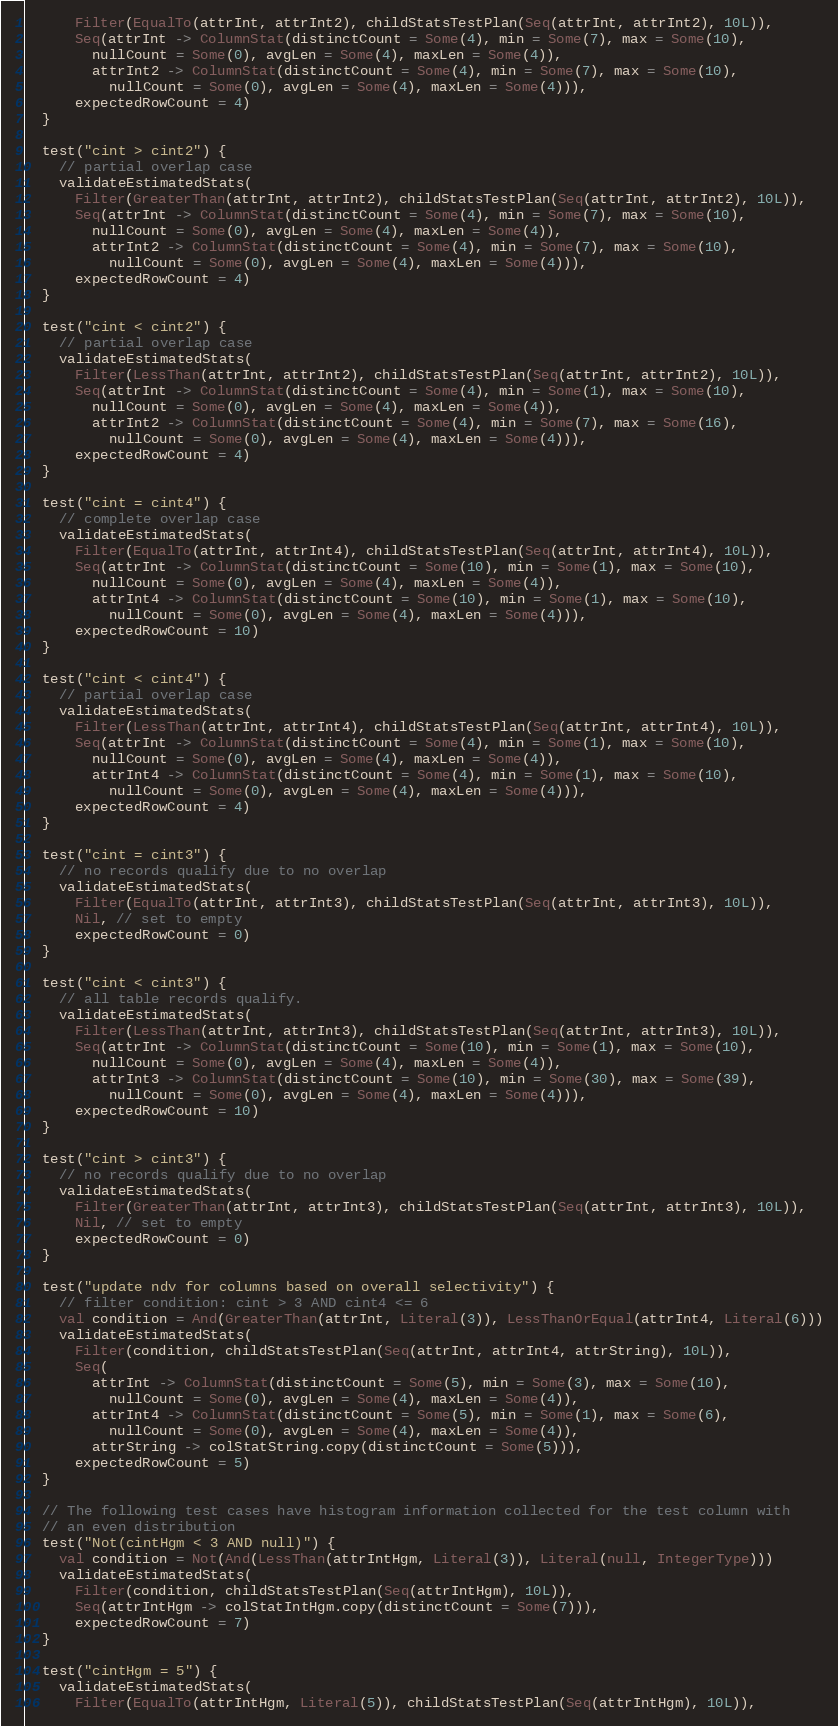<code> <loc_0><loc_0><loc_500><loc_500><_Scala_>      Filter(EqualTo(attrInt, attrInt2), childStatsTestPlan(Seq(attrInt, attrInt2), 10L)),
      Seq(attrInt -> ColumnStat(distinctCount = Some(4), min = Some(7), max = Some(10),
        nullCount = Some(0), avgLen = Some(4), maxLen = Some(4)),
        attrInt2 -> ColumnStat(distinctCount = Some(4), min = Some(7), max = Some(10),
          nullCount = Some(0), avgLen = Some(4), maxLen = Some(4))),
      expectedRowCount = 4)
  }

  test("cint > cint2") {
    // partial overlap case
    validateEstimatedStats(
      Filter(GreaterThan(attrInt, attrInt2), childStatsTestPlan(Seq(attrInt, attrInt2), 10L)),
      Seq(attrInt -> ColumnStat(distinctCount = Some(4), min = Some(7), max = Some(10),
        nullCount = Some(0), avgLen = Some(4), maxLen = Some(4)),
        attrInt2 -> ColumnStat(distinctCount = Some(4), min = Some(7), max = Some(10),
          nullCount = Some(0), avgLen = Some(4), maxLen = Some(4))),
      expectedRowCount = 4)
  }

  test("cint < cint2") {
    // partial overlap case
    validateEstimatedStats(
      Filter(LessThan(attrInt, attrInt2), childStatsTestPlan(Seq(attrInt, attrInt2), 10L)),
      Seq(attrInt -> ColumnStat(distinctCount = Some(4), min = Some(1), max = Some(10),
        nullCount = Some(0), avgLen = Some(4), maxLen = Some(4)),
        attrInt2 -> ColumnStat(distinctCount = Some(4), min = Some(7), max = Some(16),
          nullCount = Some(0), avgLen = Some(4), maxLen = Some(4))),
      expectedRowCount = 4)
  }

  test("cint = cint4") {
    // complete overlap case
    validateEstimatedStats(
      Filter(EqualTo(attrInt, attrInt4), childStatsTestPlan(Seq(attrInt, attrInt4), 10L)),
      Seq(attrInt -> ColumnStat(distinctCount = Some(10), min = Some(1), max = Some(10),
        nullCount = Some(0), avgLen = Some(4), maxLen = Some(4)),
        attrInt4 -> ColumnStat(distinctCount = Some(10), min = Some(1), max = Some(10),
          nullCount = Some(0), avgLen = Some(4), maxLen = Some(4))),
      expectedRowCount = 10)
  }

  test("cint < cint4") {
    // partial overlap case
    validateEstimatedStats(
      Filter(LessThan(attrInt, attrInt4), childStatsTestPlan(Seq(attrInt, attrInt4), 10L)),
      Seq(attrInt -> ColumnStat(distinctCount = Some(4), min = Some(1), max = Some(10),
        nullCount = Some(0), avgLen = Some(4), maxLen = Some(4)),
        attrInt4 -> ColumnStat(distinctCount = Some(4), min = Some(1), max = Some(10),
          nullCount = Some(0), avgLen = Some(4), maxLen = Some(4))),
      expectedRowCount = 4)
  }

  test("cint = cint3") {
    // no records qualify due to no overlap
    validateEstimatedStats(
      Filter(EqualTo(attrInt, attrInt3), childStatsTestPlan(Seq(attrInt, attrInt3), 10L)),
      Nil, // set to empty
      expectedRowCount = 0)
  }

  test("cint < cint3") {
    // all table records qualify.
    validateEstimatedStats(
      Filter(LessThan(attrInt, attrInt3), childStatsTestPlan(Seq(attrInt, attrInt3), 10L)),
      Seq(attrInt -> ColumnStat(distinctCount = Some(10), min = Some(1), max = Some(10),
        nullCount = Some(0), avgLen = Some(4), maxLen = Some(4)),
        attrInt3 -> ColumnStat(distinctCount = Some(10), min = Some(30), max = Some(39),
          nullCount = Some(0), avgLen = Some(4), maxLen = Some(4))),
      expectedRowCount = 10)
  }

  test("cint > cint3") {
    // no records qualify due to no overlap
    validateEstimatedStats(
      Filter(GreaterThan(attrInt, attrInt3), childStatsTestPlan(Seq(attrInt, attrInt3), 10L)),
      Nil, // set to empty
      expectedRowCount = 0)
  }

  test("update ndv for columns based on overall selectivity") {
    // filter condition: cint > 3 AND cint4 <= 6
    val condition = And(GreaterThan(attrInt, Literal(3)), LessThanOrEqual(attrInt4, Literal(6)))
    validateEstimatedStats(
      Filter(condition, childStatsTestPlan(Seq(attrInt, attrInt4, attrString), 10L)),
      Seq(
        attrInt -> ColumnStat(distinctCount = Some(5), min = Some(3), max = Some(10),
          nullCount = Some(0), avgLen = Some(4), maxLen = Some(4)),
        attrInt4 -> ColumnStat(distinctCount = Some(5), min = Some(1), max = Some(6),
          nullCount = Some(0), avgLen = Some(4), maxLen = Some(4)),
        attrString -> colStatString.copy(distinctCount = Some(5))),
      expectedRowCount = 5)
  }

  // The following test cases have histogram information collected for the test column with
  // an even distribution
  test("Not(cintHgm < 3 AND null)") {
    val condition = Not(And(LessThan(attrIntHgm, Literal(3)), Literal(null, IntegerType)))
    validateEstimatedStats(
      Filter(condition, childStatsTestPlan(Seq(attrIntHgm), 10L)),
      Seq(attrIntHgm -> colStatIntHgm.copy(distinctCount = Some(7))),
      expectedRowCount = 7)
  }

  test("cintHgm = 5") {
    validateEstimatedStats(
      Filter(EqualTo(attrIntHgm, Literal(5)), childStatsTestPlan(Seq(attrIntHgm), 10L)),</code> 